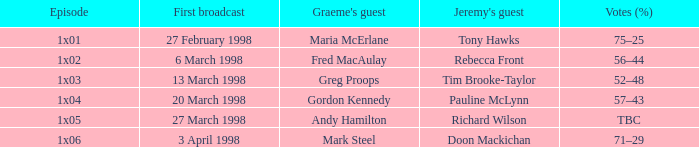When was the first airing of the episode with jeremy's guest, tim brooke-taylor? 13 March 1998. 